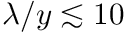<formula> <loc_0><loc_0><loc_500><loc_500>\lambda / y \lesssim 1 0</formula> 